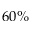<formula> <loc_0><loc_0><loc_500><loc_500>6 0 \%</formula> 